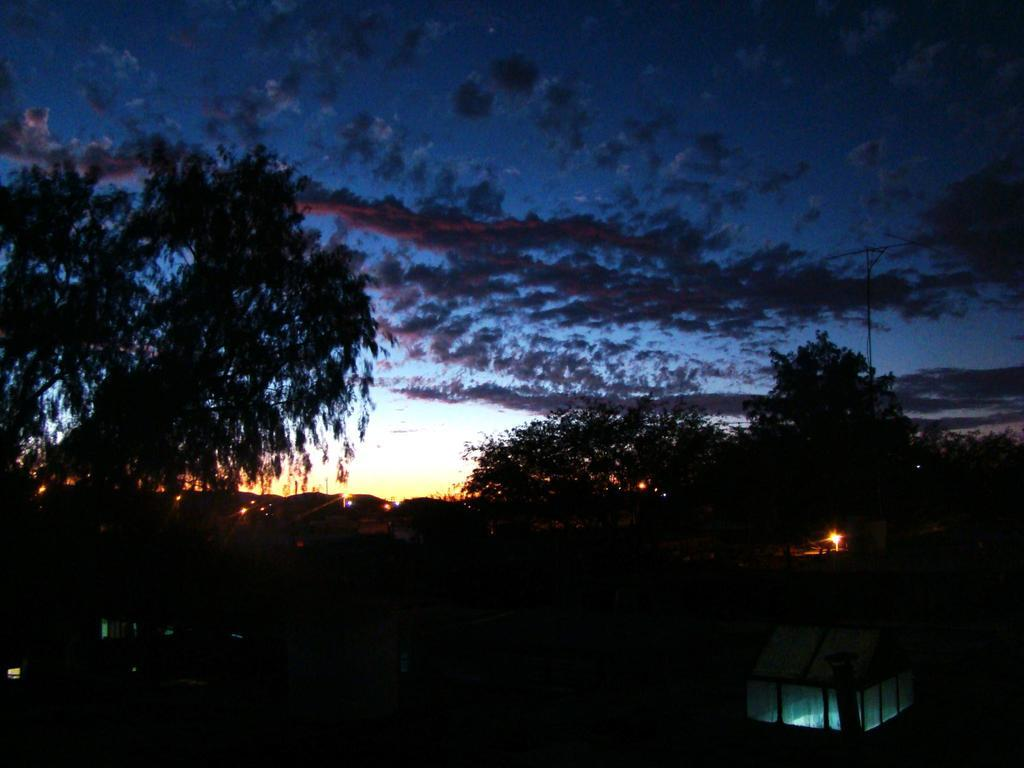What type of natural elements can be seen in the image? There are trees in the image. What type of objects are made of glass in the image? There are glass objects in the image. How would you describe the lighting in the image? The view in the image is dark. What is the condition of the sky in the background of the image? There is a cloudy sky visible in the background. What type of structure can be seen in the background of the image? There is an antenna in the background. What type of canvas is visible in the image? There is no canvas present in the image. What type of sofa can be seen in the image? There is no sofa present in the image. 